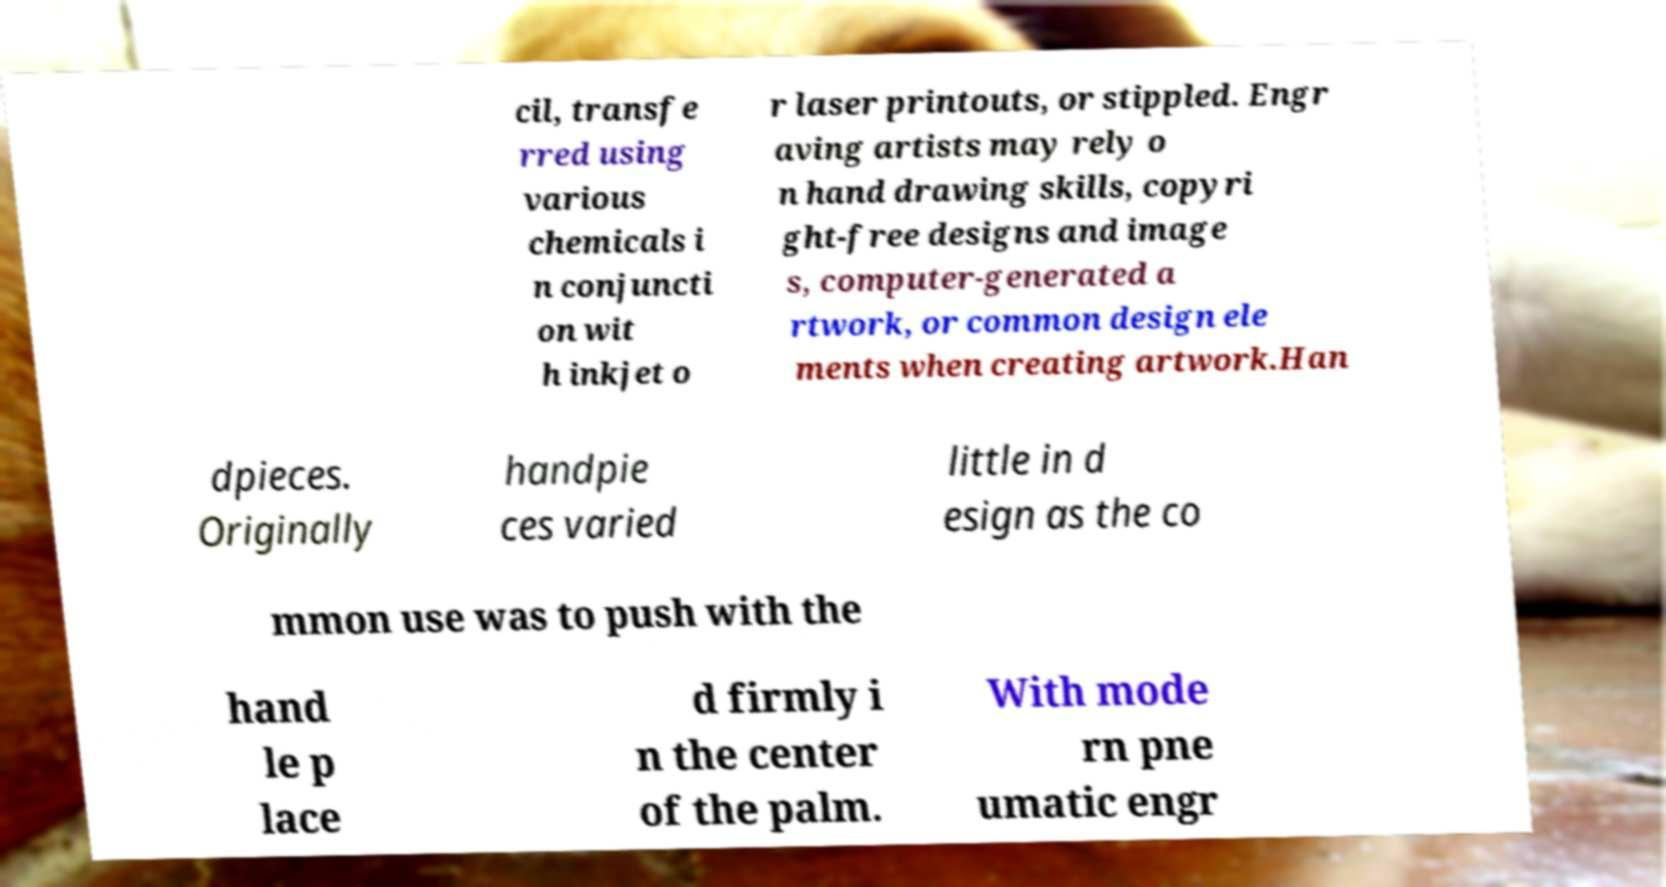Can you read and provide the text displayed in the image?This photo seems to have some interesting text. Can you extract and type it out for me? cil, transfe rred using various chemicals i n conjuncti on wit h inkjet o r laser printouts, or stippled. Engr aving artists may rely o n hand drawing skills, copyri ght-free designs and image s, computer-generated a rtwork, or common design ele ments when creating artwork.Han dpieces. Originally handpie ces varied little in d esign as the co mmon use was to push with the hand le p lace d firmly i n the center of the palm. With mode rn pne umatic engr 